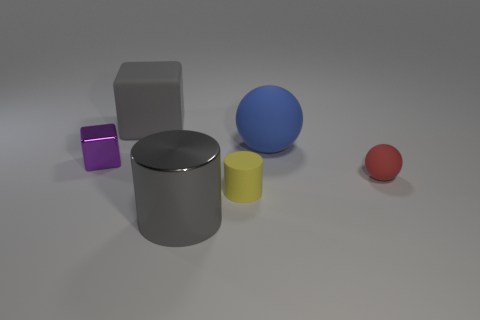What number of blocks are the same color as the big metallic cylinder?
Provide a succinct answer. 1. Are the small sphere and the large blue thing made of the same material?
Your response must be concise. Yes. The metal object that is left of the object in front of the yellow cylinder is what color?
Give a very brief answer. Purple. The metallic object that is the same shape as the gray rubber object is what size?
Provide a short and direct response. Small. Is the metallic block the same color as the large block?
Offer a terse response. No. There is a yellow rubber thing that is in front of the matte object that is on the left side of the yellow thing; what number of large things are in front of it?
Offer a very short reply. 1. Is the number of gray metallic balls greater than the number of large gray objects?
Provide a succinct answer. No. How many small gray shiny objects are there?
Your answer should be very brief. 0. What shape is the big gray object in front of the metallic object on the left side of the cube that is behind the purple object?
Make the answer very short. Cylinder. Is the number of blue balls that are to the right of the big gray metallic cylinder less than the number of yellow objects that are behind the tiny cylinder?
Offer a terse response. No. 